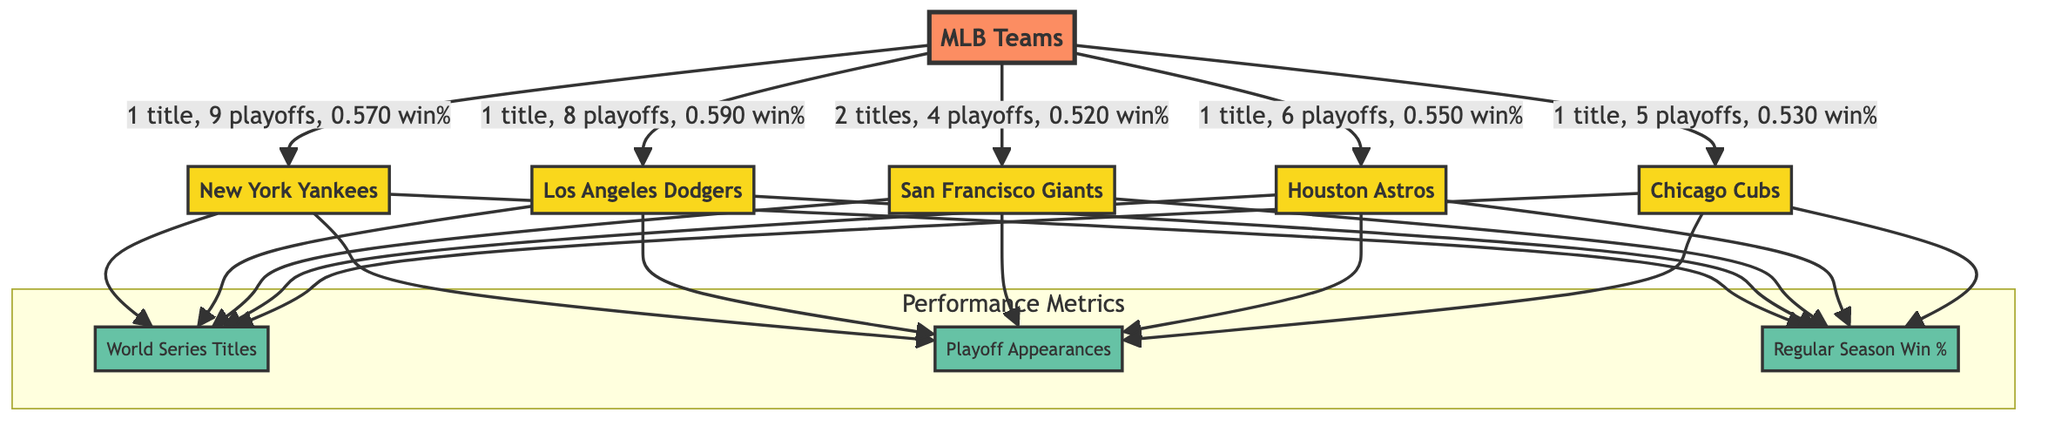What is the total number of titles won by the San Francisco Giants? The diagram shows that the San Francisco Giants have won "2 titles," which is indicated next to their node in the diagram.
Answer: 2 How many playoff appearances did the Los Angeles Dodgers have? The diagram indicates that the Los Angeles Dodgers had "8 playoffs," which is shown in the relationship between the MLB node and the LAD node.
Answer: 8 Which team has the highest regular season win percentage? By comparing the win percentages of the teams in the diagram, the Los Angeles Dodgers have a "0.590 win%" which is the highest among the teams listed.
Answer: 0.590 How many teams have won exactly one World Series title? Counting the nodes, we can see that the New York Yankees, Los Angeles Dodgers, Houston Astros, and Chicago Cubs each have "1 title," resulting in a total of four teams with one World Series title.
Answer: 4 Which team has the lowest playoff appearances? The diagram shows that the San Francisco Giants have "4 playoffs," while all other teams have more. Therefore, the San Francisco Giants have the lowest playoff appearances.
Answer: San Francisco Giants What is the relationship between the New York Yankees and their playoff appearances? The relationship states that the New York Yankees have "1 title, 9 playoffs, 0.570 win%," indicating that their playoff appearances are directly detailed next to the Yankees node as part of their performance metrics.
Answer: 9 Which team has a regular season win percentage below 0.530? The diagram shows the regular season win percentages for all teams. The Chicago Cubs have a "0.530 win%" which is the lowest percentage compared to others.
Answer: Chicago Cubs What color represents the performance metrics in the diagram? The color code indicates that the performance nodes (World Series Titles, Playoff Appearances, Regular Season Win %) are filled with "#66c2a5," which is the assigned color for performance nodes.
Answer: #66c2a5 